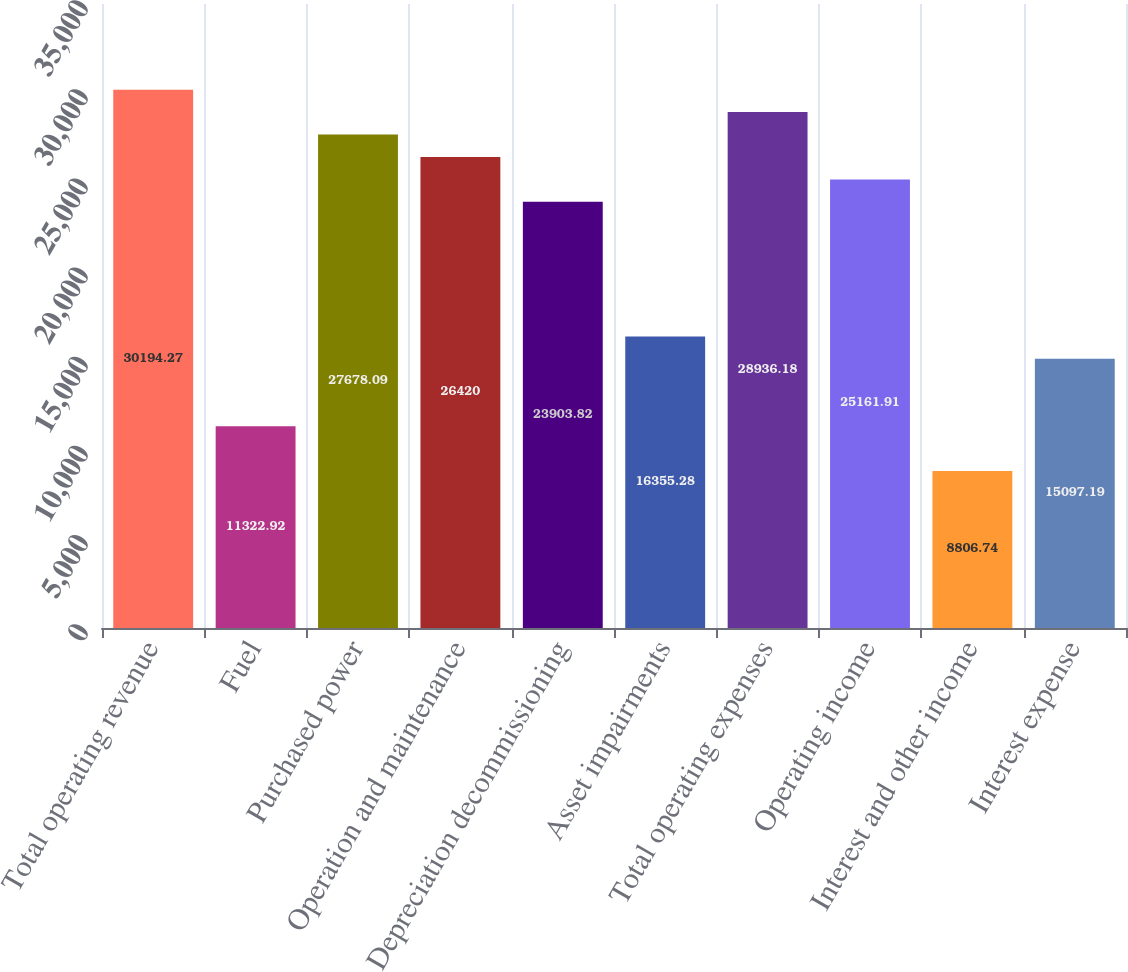Convert chart to OTSL. <chart><loc_0><loc_0><loc_500><loc_500><bar_chart><fcel>Total operating revenue<fcel>Fuel<fcel>Purchased power<fcel>Operation and maintenance<fcel>Depreciation decommissioning<fcel>Asset impairments<fcel>Total operating expenses<fcel>Operating income<fcel>Interest and other income<fcel>Interest expense<nl><fcel>30194.3<fcel>11322.9<fcel>27678.1<fcel>26420<fcel>23903.8<fcel>16355.3<fcel>28936.2<fcel>25161.9<fcel>8806.74<fcel>15097.2<nl></chart> 